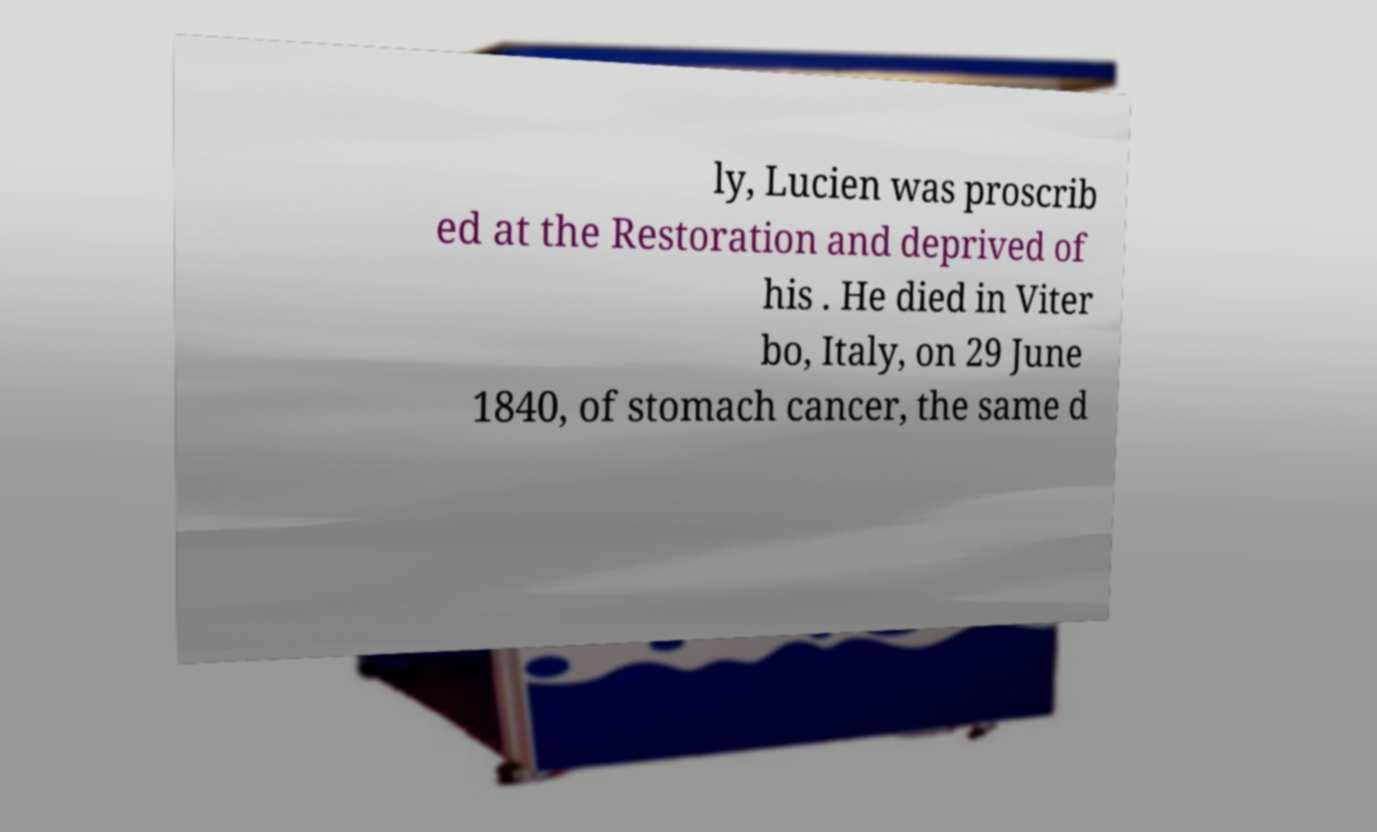Can you read and provide the text displayed in the image?This photo seems to have some interesting text. Can you extract and type it out for me? ly, Lucien was proscrib ed at the Restoration and deprived of his . He died in Viter bo, Italy, on 29 June 1840, of stomach cancer, the same d 